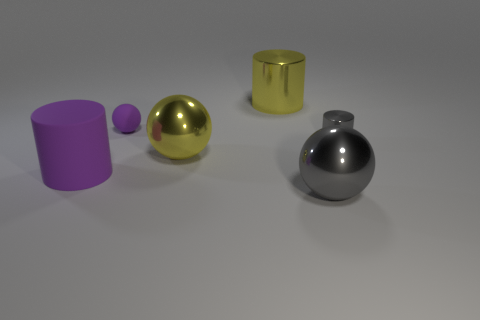Add 2 large red shiny cubes. How many objects exist? 8 Add 6 purple rubber things. How many purple rubber things are left? 8 Add 3 yellow metal cylinders. How many yellow metal cylinders exist? 4 Subtract 0 yellow cubes. How many objects are left? 6 Subtract all small brown rubber cylinders. Subtract all purple rubber balls. How many objects are left? 5 